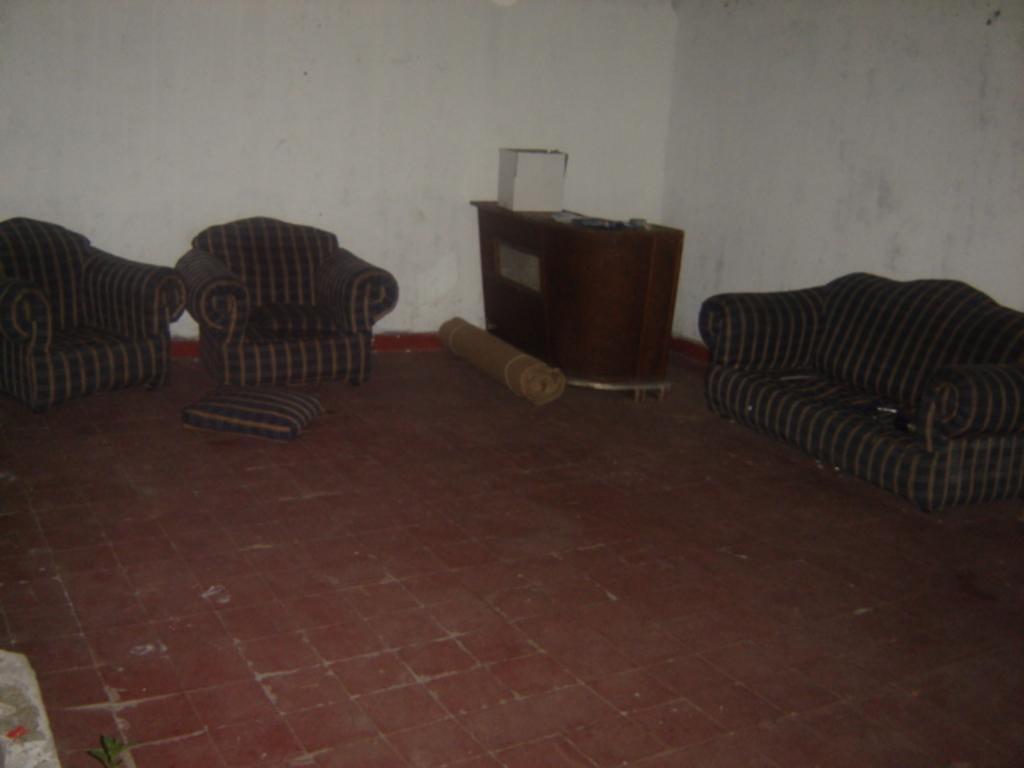Could you give a brief overview of what you see in this image? As we can see in the image there is a white color wall, pillow, mat and sofas. 